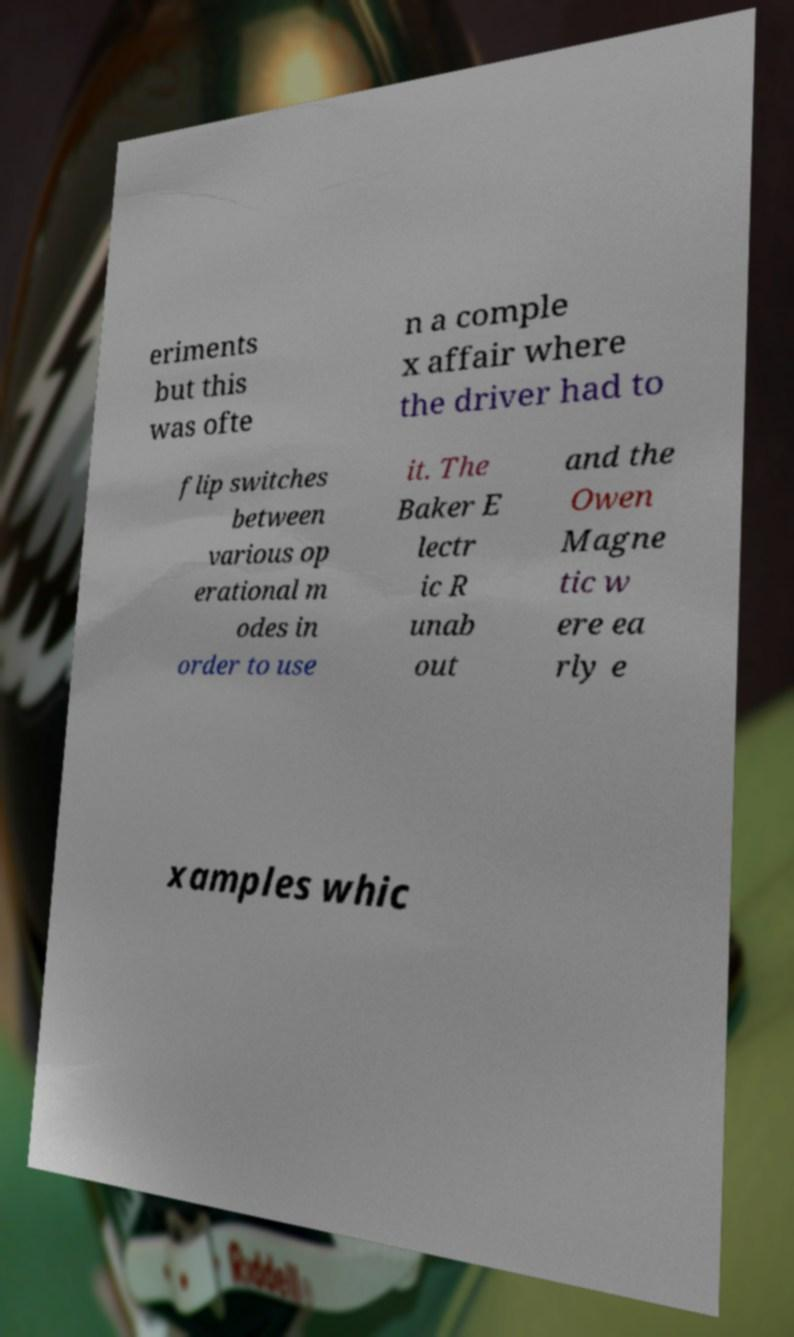Can you read and provide the text displayed in the image?This photo seems to have some interesting text. Can you extract and type it out for me? eriments but this was ofte n a comple x affair where the driver had to flip switches between various op erational m odes in order to use it. The Baker E lectr ic R unab out and the Owen Magne tic w ere ea rly e xamples whic 